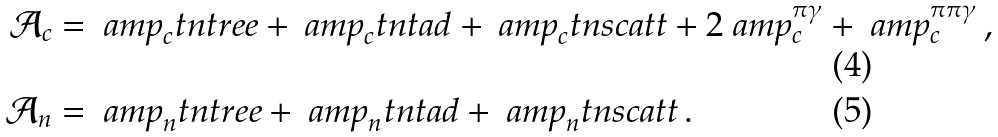<formula> <loc_0><loc_0><loc_500><loc_500>\mathcal { A } _ { c } & = \ a m p _ { c } ^ { \ } t n { t r e e } + \ a m p _ { c } ^ { \ } t n { t a d } + \ a m p _ { c } ^ { \ } t n { s c a t t } + 2 \ a m p _ { c } ^ { \pi \gamma } + \ a m p _ { c } ^ { \pi \pi \gamma } \, , \\ \mathcal { A } _ { n } & = \ a m p _ { n } ^ { \ } t n { t r e e } + \ a m p _ { n } ^ { \ } t n { t a d } + \ a m p _ { n } ^ { \ } t n { s c a t t } \, .</formula> 